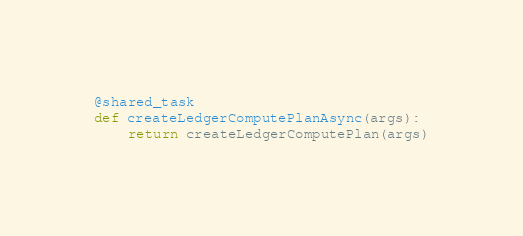<code> <loc_0><loc_0><loc_500><loc_500><_Python_>

@shared_task
def createLedgerComputePlanAsync(args):
    return createLedgerComputePlan(args)
</code> 